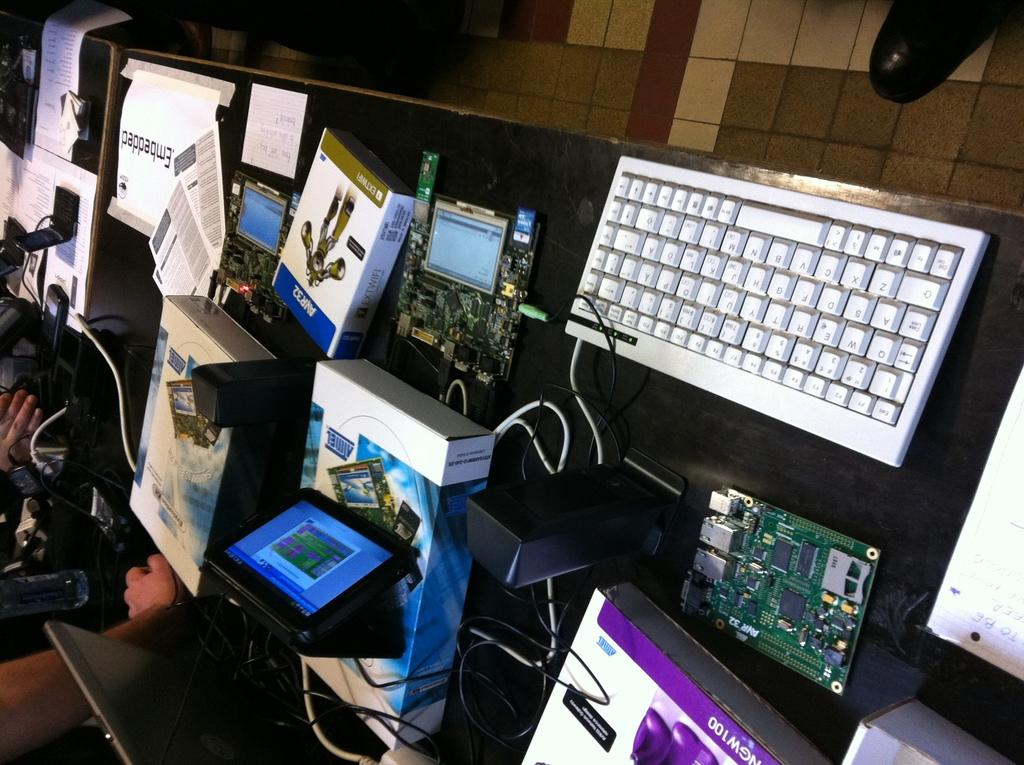<image>
Summarize the visual content of the image. On display on this counter are various boxes including one labeled extwifi. 